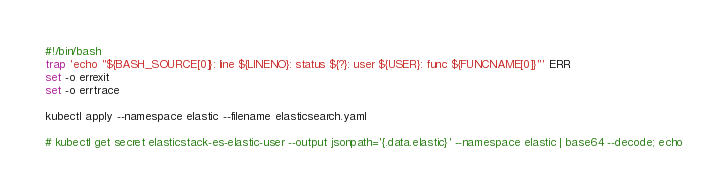<code> <loc_0><loc_0><loc_500><loc_500><_Bash_>#!/bin/bash
trap 'echo "${BASH_SOURCE[0]}: line ${LINENO}: status ${?}: user ${USER}: func ${FUNCNAME[0]}"' ERR
set -o errexit
set -o errtrace

kubectl apply --namespace elastic --filename elasticsearch.yaml

# kubectl get secret elasticstack-es-elastic-user --output jsonpath='{.data.elastic}' --namespace elastic | base64 --decode; echo
</code> 